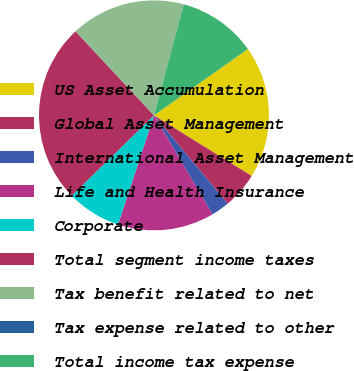Convert chart. <chart><loc_0><loc_0><loc_500><loc_500><pie_chart><fcel>US Asset Accumulation<fcel>Global Asset Management<fcel>International Asset Management<fcel>Life and Health Insurance<fcel>Corporate<fcel>Total segment income taxes<fcel>Tax benefit related to net<fcel>Tax expense related to other<fcel>Total income tax expense<nl><fcel>18.63%<fcel>5.1%<fcel>2.57%<fcel>13.56%<fcel>7.63%<fcel>25.36%<fcel>16.1%<fcel>0.03%<fcel>11.03%<nl></chart> 